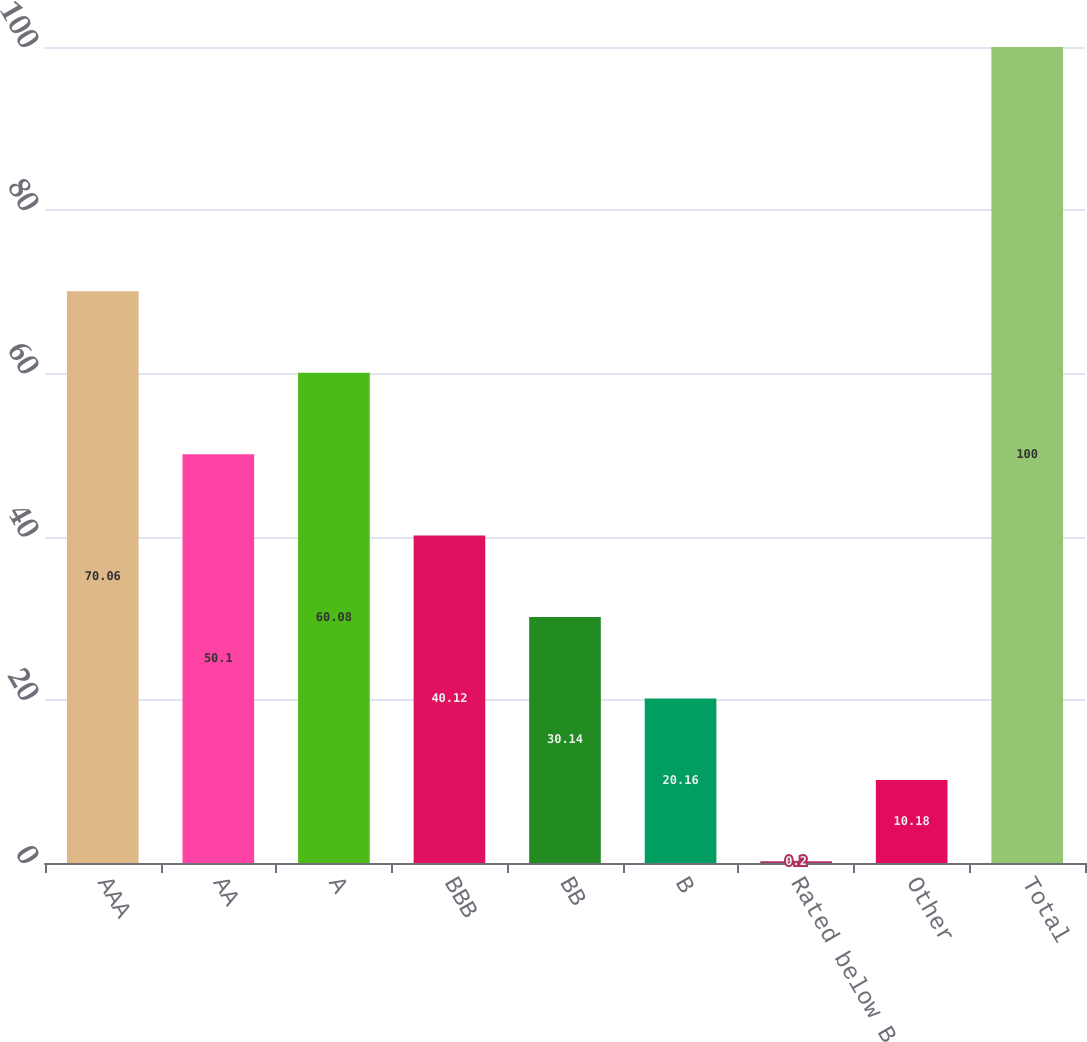<chart> <loc_0><loc_0><loc_500><loc_500><bar_chart><fcel>AAA<fcel>AA<fcel>A<fcel>BBB<fcel>BB<fcel>B<fcel>Rated below B<fcel>Other<fcel>Total<nl><fcel>70.06<fcel>50.1<fcel>60.08<fcel>40.12<fcel>30.14<fcel>20.16<fcel>0.2<fcel>10.18<fcel>100<nl></chart> 